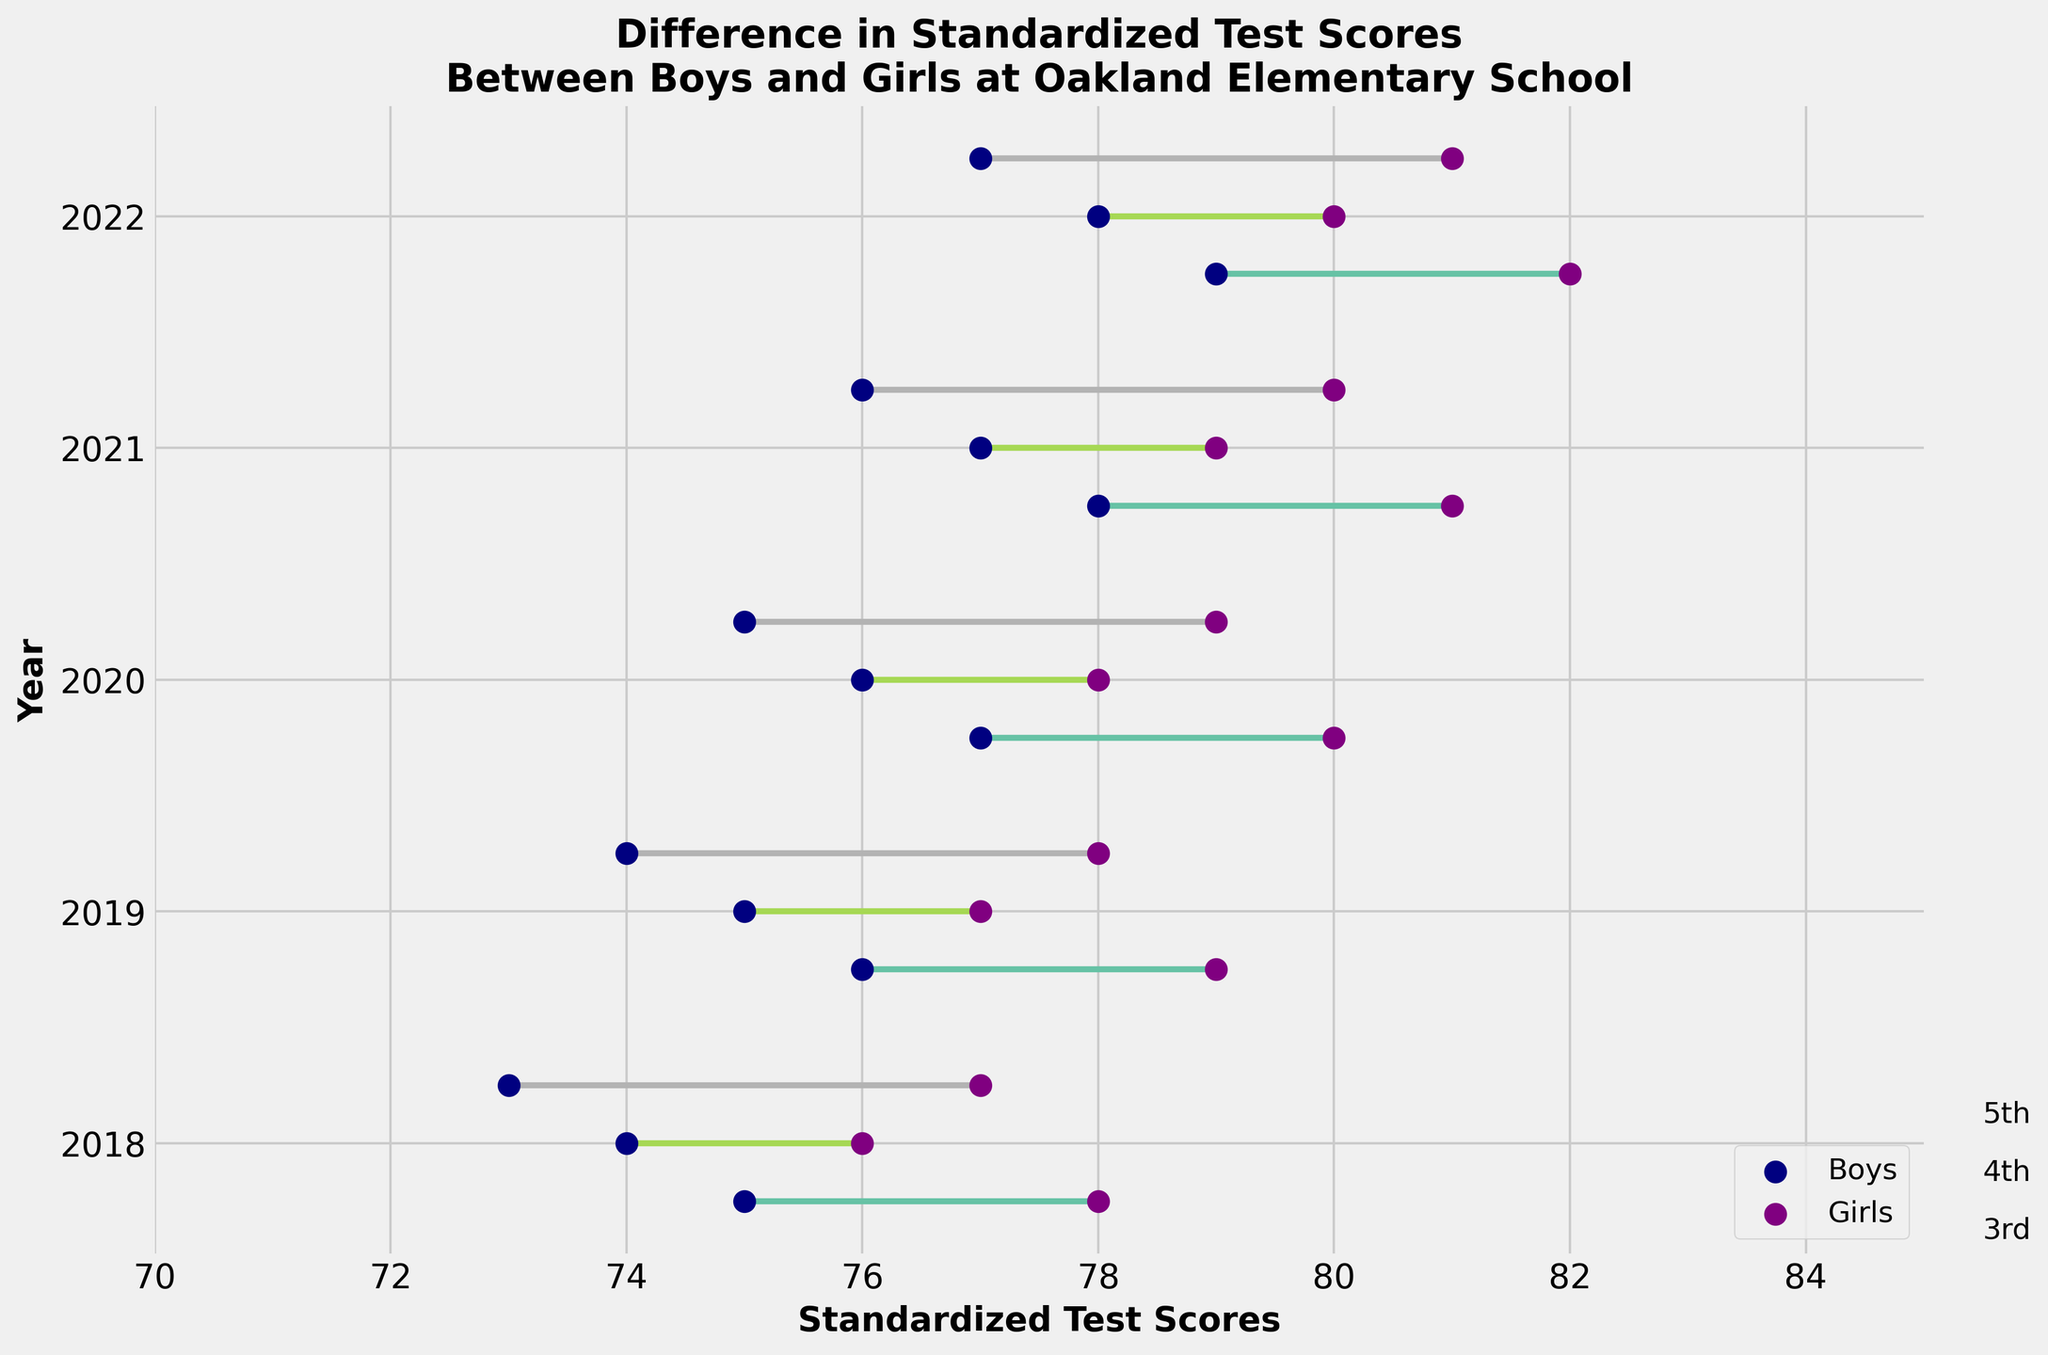What is the title of the plot? The title is typically located at the top of the plot and usually summarizes the main topic or finding. Here, it reads "Difference in Standardized Test Scores Between Boys and Girls at Oakland Elementary School".
Answer: Difference in Standardized Test Scores Between Boys and Girls at Oakland Elementary School What are the labels on the x-axis and y-axis? The labels on the x-axis and y-axis help to understand what the scales represent. The x-axis label is "Standardized Test Scores" and the y-axis label is "Year".
Answer: Standardized Test Scores, Year Which grade had the smallest difference in scores between boys and girls in 2018? To find the smallest difference, we need to evaluate the differences for each grade in 2018 (3rd, 4th, 5th) and determine the smallest one. For 3rd grade: 78-75=3, for 4th grade: 76-74=2, and for 5th grade: 77-73=4. The smallest difference is in the 4th grade.
Answer: 4th How did the boys' scores in 3rd grade change from 2018 to 2022? Track the boys' scores for 3rd grade across the years 2018 to 2022. Notice the following: in 2018: 75, 2019: 76, 2020: 77, 2021: 78, 2022: 79. The score increased by 4 points.
Answer: Increased by 4 points Which year and grade show the largest difference in scores between boys and girls? Evaluate the differences over all years and grades. We need to find the year and grade with the maximum value when subtracting boys' scores from girls' scores. The largest difference is for the 3rd grade in 2022 (82-79=3).
Answer: 2022, 3rd What is the average score of girls across all grades in 2020? Sum the girls' scores in 2020 across all three grades and divide by 3 to find the average. For 3rd grade: 80, for 4th grade: 78, for 5th grade: 79. The average is (80+78+79)/3 = 79.
Answer: 79 Compare the trend of boys' scores in 5th grade to girls' scores in 5th grade from 2018 to 2022. How do they differ? Examine 5th grade boys' and girls' scores across the years: Boys' scores: 73, 74, 75, 76, 77; Girls' scores: 77, 78, 79, 80, 81. Both scores steadily increased year by year, but the girls' scores were consistently higher by a fixed gap of 4 points each year.
Answer: Both increased steadily, girls' scores consistently higher by 4 points Between boys and girls in 4th grade, who performed better in 2019? To determine who performed better, compare the boys' and girls' scores in 4th grade in 2019. Boys had a score of 75 and girls had a score of 77. Girls performed better.
Answer: Girls What color is used to represent the girls' scores in this plot? The color used to represent the girls' scores can be identified by looking at the plot's legend. The color corresponding to 'Girls' in the legend is purple.
Answer: Purple What is the overall trend in the difference of scores between boys and girls over the five years? To identify the trend, look at the differences year by year across all grades. The differences show a consistent 3-4 point difference each year, indicating a steady trend without significant changes.
Answer: Steady trend, girls consistently scoring higher by 3-4 points 